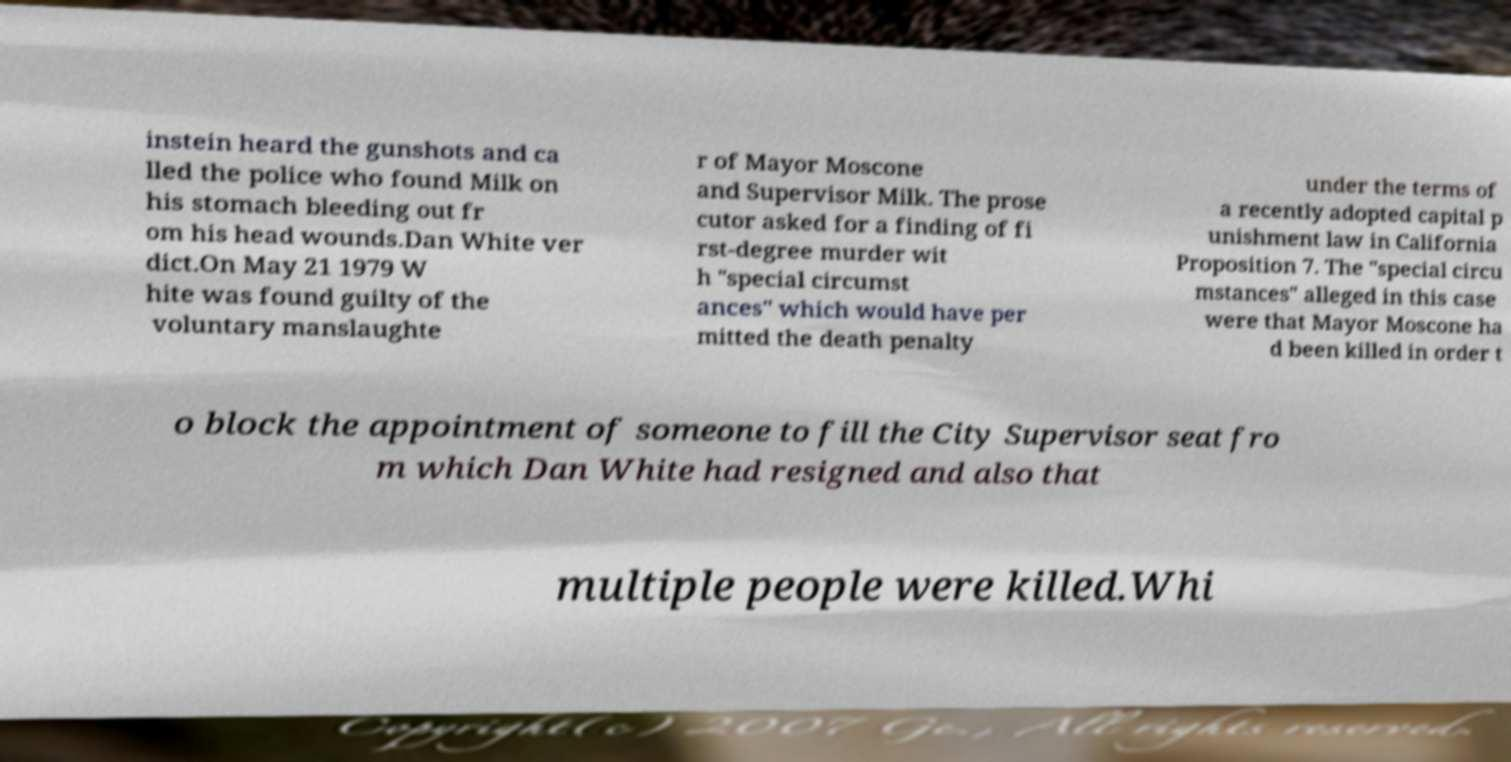Could you extract and type out the text from this image? instein heard the gunshots and ca lled the police who found Milk on his stomach bleeding out fr om his head wounds.Dan White ver dict.On May 21 1979 W hite was found guilty of the voluntary manslaughte r of Mayor Moscone and Supervisor Milk. The prose cutor asked for a finding of fi rst-degree murder wit h "special circumst ances" which would have per mitted the death penalty under the terms of a recently adopted capital p unishment law in California Proposition 7. The "special circu mstances" alleged in this case were that Mayor Moscone ha d been killed in order t o block the appointment of someone to fill the City Supervisor seat fro m which Dan White had resigned and also that multiple people were killed.Whi 